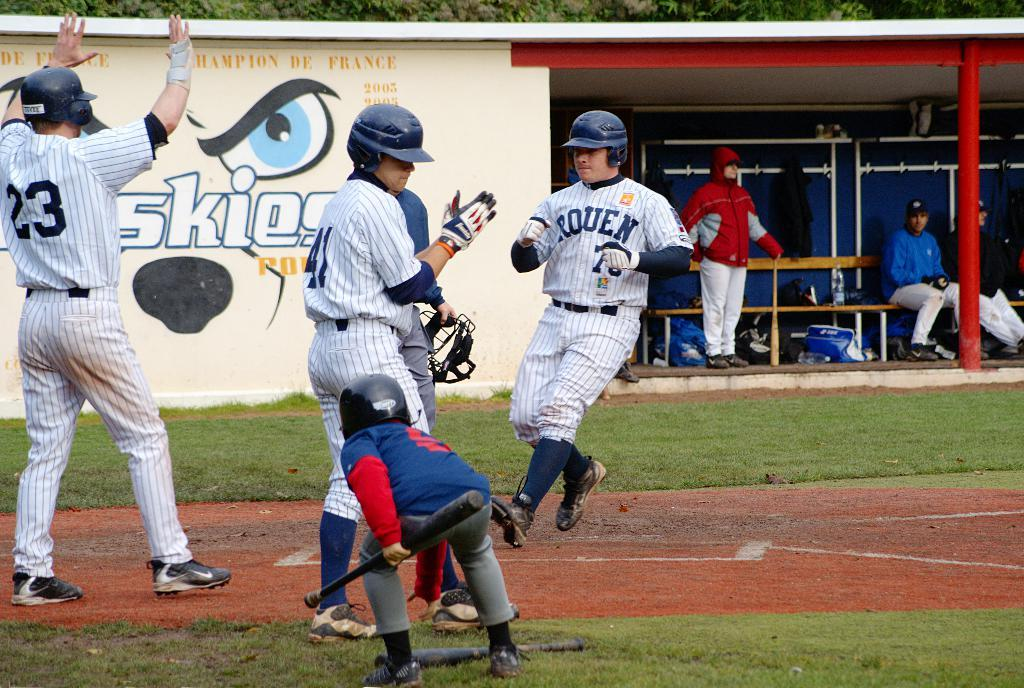Provide a one-sentence caption for the provided image. The Rouen baseball player just scored a run. 